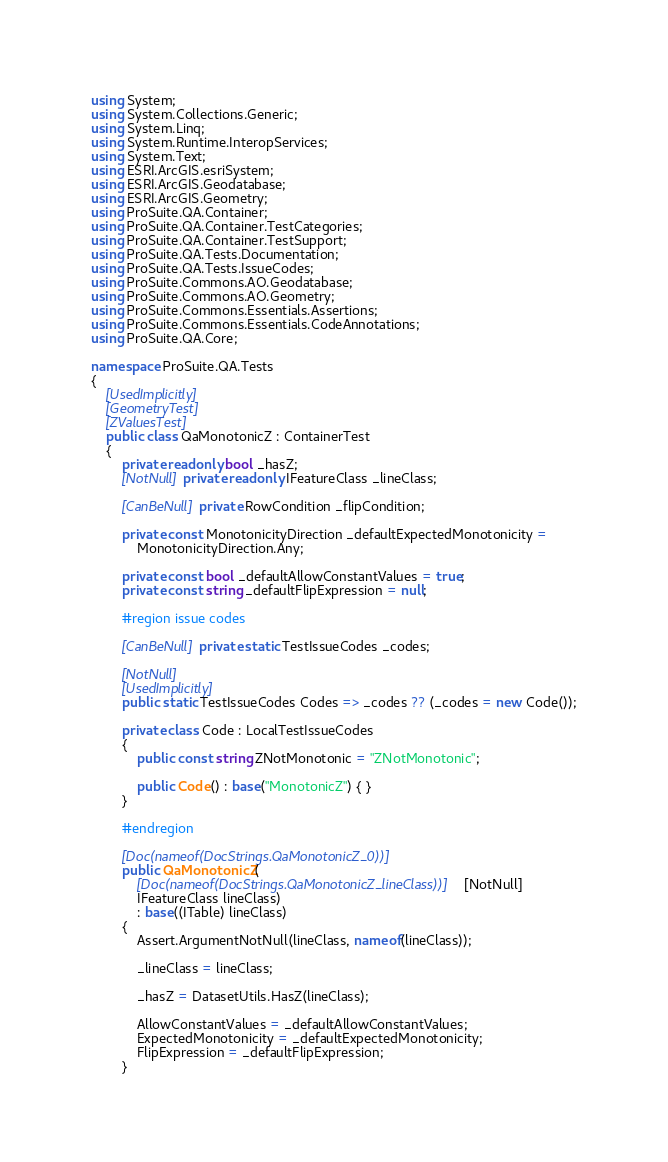Convert code to text. <code><loc_0><loc_0><loc_500><loc_500><_C#_>using System;
using System.Collections.Generic;
using System.Linq;
using System.Runtime.InteropServices;
using System.Text;
using ESRI.ArcGIS.esriSystem;
using ESRI.ArcGIS.Geodatabase;
using ESRI.ArcGIS.Geometry;
using ProSuite.QA.Container;
using ProSuite.QA.Container.TestCategories;
using ProSuite.QA.Container.TestSupport;
using ProSuite.QA.Tests.Documentation;
using ProSuite.QA.Tests.IssueCodes;
using ProSuite.Commons.AO.Geodatabase;
using ProSuite.Commons.AO.Geometry;
using ProSuite.Commons.Essentials.Assertions;
using ProSuite.Commons.Essentials.CodeAnnotations;
using ProSuite.QA.Core;

namespace ProSuite.QA.Tests
{
	[UsedImplicitly]
	[GeometryTest]
	[ZValuesTest]
	public class QaMonotonicZ : ContainerTest
	{
		private readonly bool _hasZ;
		[NotNull] private readonly IFeatureClass _lineClass;

		[CanBeNull] private RowCondition _flipCondition;

		private const MonotonicityDirection _defaultExpectedMonotonicity =
			MonotonicityDirection.Any;

		private const bool _defaultAllowConstantValues = true;
		private const string _defaultFlipExpression = null;

		#region issue codes

		[CanBeNull] private static TestIssueCodes _codes;

		[NotNull]
		[UsedImplicitly]
		public static TestIssueCodes Codes => _codes ?? (_codes = new Code());

		private class Code : LocalTestIssueCodes
		{
			public const string ZNotMonotonic = "ZNotMonotonic";

			public Code() : base("MonotonicZ") { }
		}

		#endregion

		[Doc(nameof(DocStrings.QaMonotonicZ_0))]
		public QaMonotonicZ(
			[Doc(nameof(DocStrings.QaMonotonicZ_lineClass))] [NotNull]
			IFeatureClass lineClass)
			: base((ITable) lineClass)
		{
			Assert.ArgumentNotNull(lineClass, nameof(lineClass));

			_lineClass = lineClass;

			_hasZ = DatasetUtils.HasZ(lineClass);

			AllowConstantValues = _defaultAllowConstantValues;
			ExpectedMonotonicity = _defaultExpectedMonotonicity;
			FlipExpression = _defaultFlipExpression;
		}
</code> 